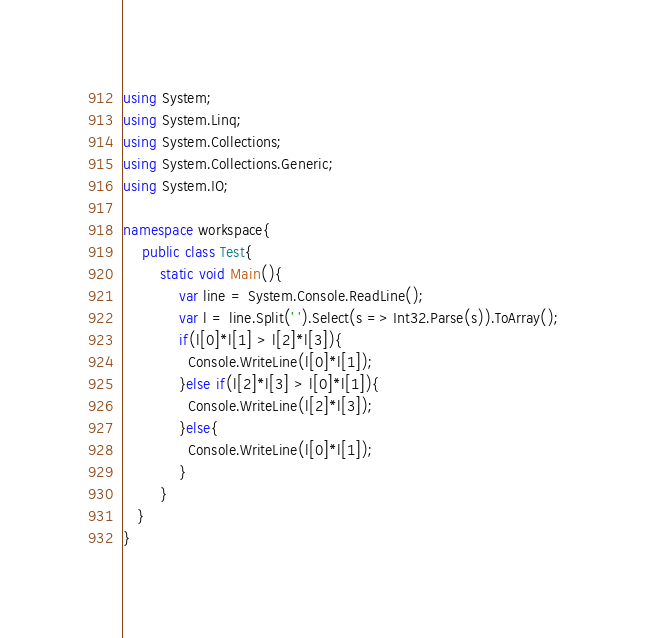Convert code to text. <code><loc_0><loc_0><loc_500><loc_500><_C#_>using System;
using System.Linq;
using System.Collections;
using System.Collections.Generic;
using System.IO;
 
namespace workspace{
	public class Test{
    	static void Main(){
    		var line = System.Console.ReadLine();
        	var l = line.Split(' ').Select(s => Int32.Parse(s)).ToArray();
            if(l[0]*l[1] > l[2]*l[3]){
              Console.WriteLine(l[0]*l[1]);
            }else if(l[2]*l[3] > l[0]*l[1]){
              Console.WriteLine(l[2]*l[3]);
            }else{
              Console.WriteLine(l[0]*l[1]);
            }
    	}
   }
}</code> 